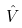<formula> <loc_0><loc_0><loc_500><loc_500>\hat { V }</formula> 